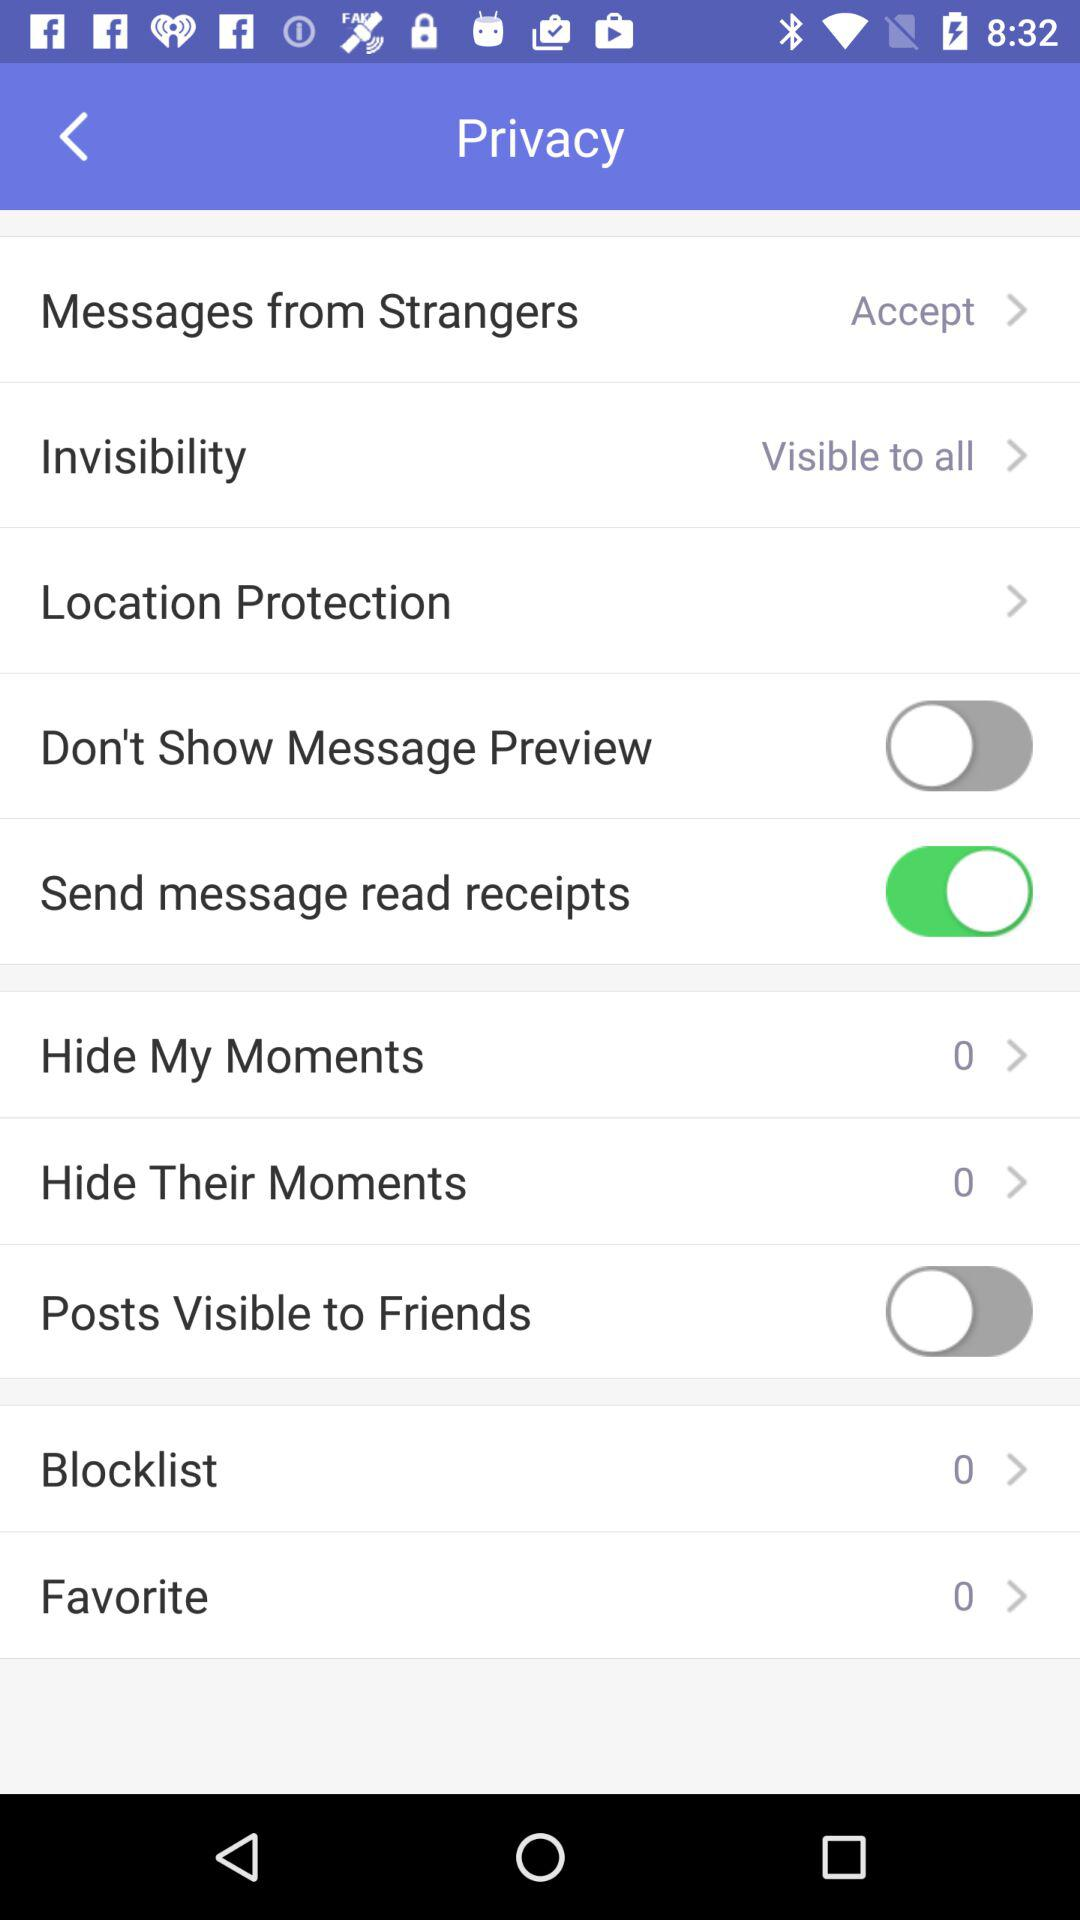What is the count of "Hide My Moments"? The count of "Hide My Moments" is 0. 